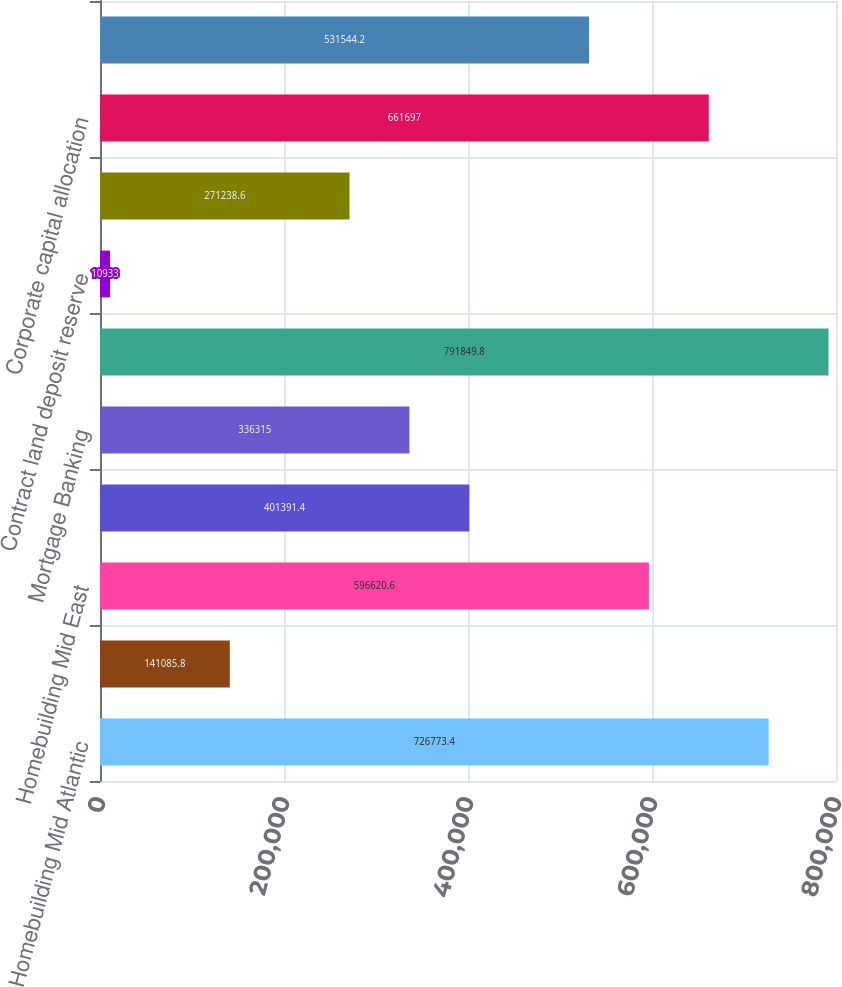<chart> <loc_0><loc_0><loc_500><loc_500><bar_chart><fcel>Homebuilding Mid Atlantic<fcel>Homebuilding North East<fcel>Homebuilding Mid East<fcel>Homebuilding South East<fcel>Mortgage Banking<fcel>Total segment profit<fcel>Contract land deposit reserve<fcel>Equity-based compensation<fcel>Corporate capital allocation<fcel>Unallocated corporate overhead<nl><fcel>726773<fcel>141086<fcel>596621<fcel>401391<fcel>336315<fcel>791850<fcel>10933<fcel>271239<fcel>661697<fcel>531544<nl></chart> 